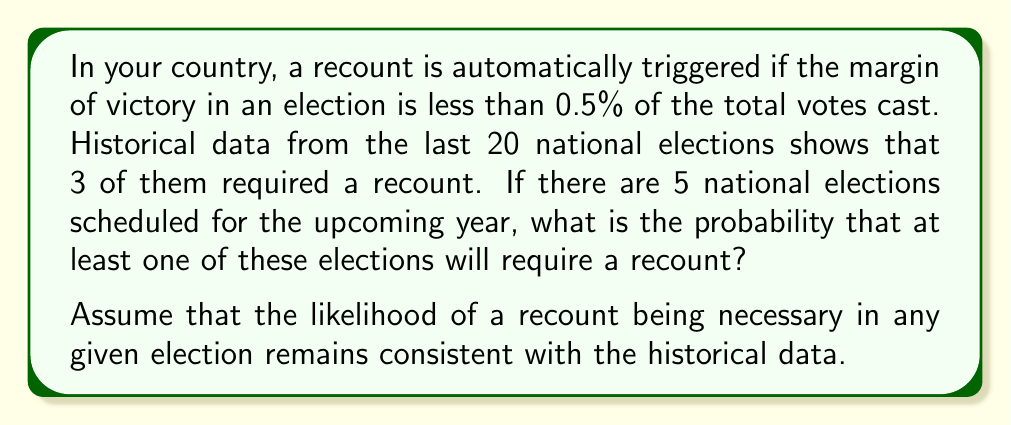Teach me how to tackle this problem. To solve this problem, we'll follow these steps:

1. Calculate the probability of a recount for a single election based on historical data.
2. Calculate the probability of no recount for a single election.
3. Calculate the probability of no recounts in all 5 elections.
4. Calculate the probability of at least one recount in the 5 elections.

Step 1: Probability of a recount for a single election
$$P(\text{recount}) = \frac{\text{Number of recounts}}{\text{Total number of elections}} = \frac{3}{20} = 0.15$$

Step 2: Probability of no recount for a single election
$$P(\text{no recount}) = 1 - P(\text{recount}) = 1 - 0.15 = 0.85$$

Step 3: Probability of no recounts in all 5 elections
Since the events are independent, we multiply the individual probabilities:
$$P(\text{no recounts in 5 elections}) = (0.85)^5 \approx 0.4437$$

Step 4: Probability of at least one recount in the 5 elections
This is the complement of the probability of no recounts:
$$P(\text{at least one recount}) = 1 - P(\text{no recounts in 5 elections})$$
$$= 1 - 0.4437 \approx 0.5563$$

Therefore, the probability that at least one of the five upcoming elections will require a recount is approximately 0.5563 or 55.63%.
Answer: The probability that at least one of the five upcoming elections will require a recount is approximately 0.5563 or 55.63%. 